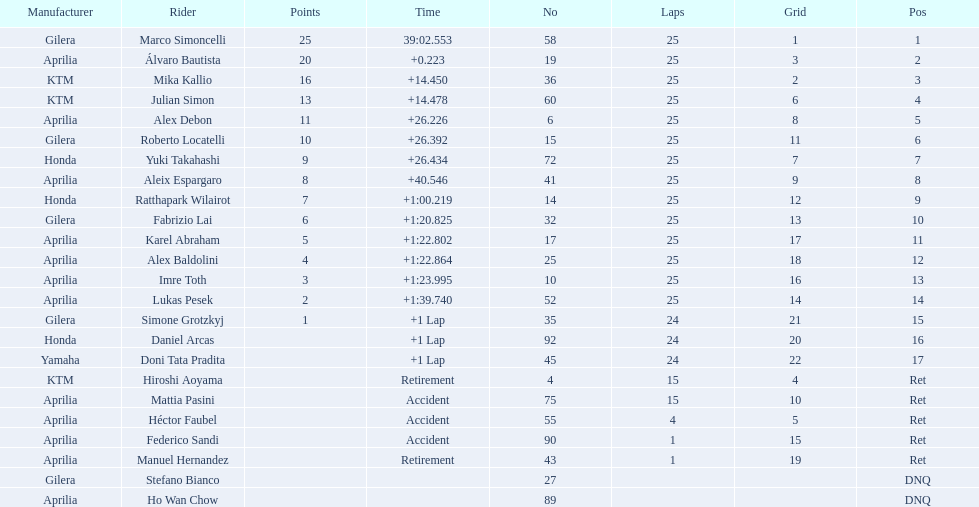What player number is marked #1 for the australian motorcycle grand prix? 58. Who is the rider that represents the #58 in the australian motorcycle grand prix? Marco Simoncelli. 